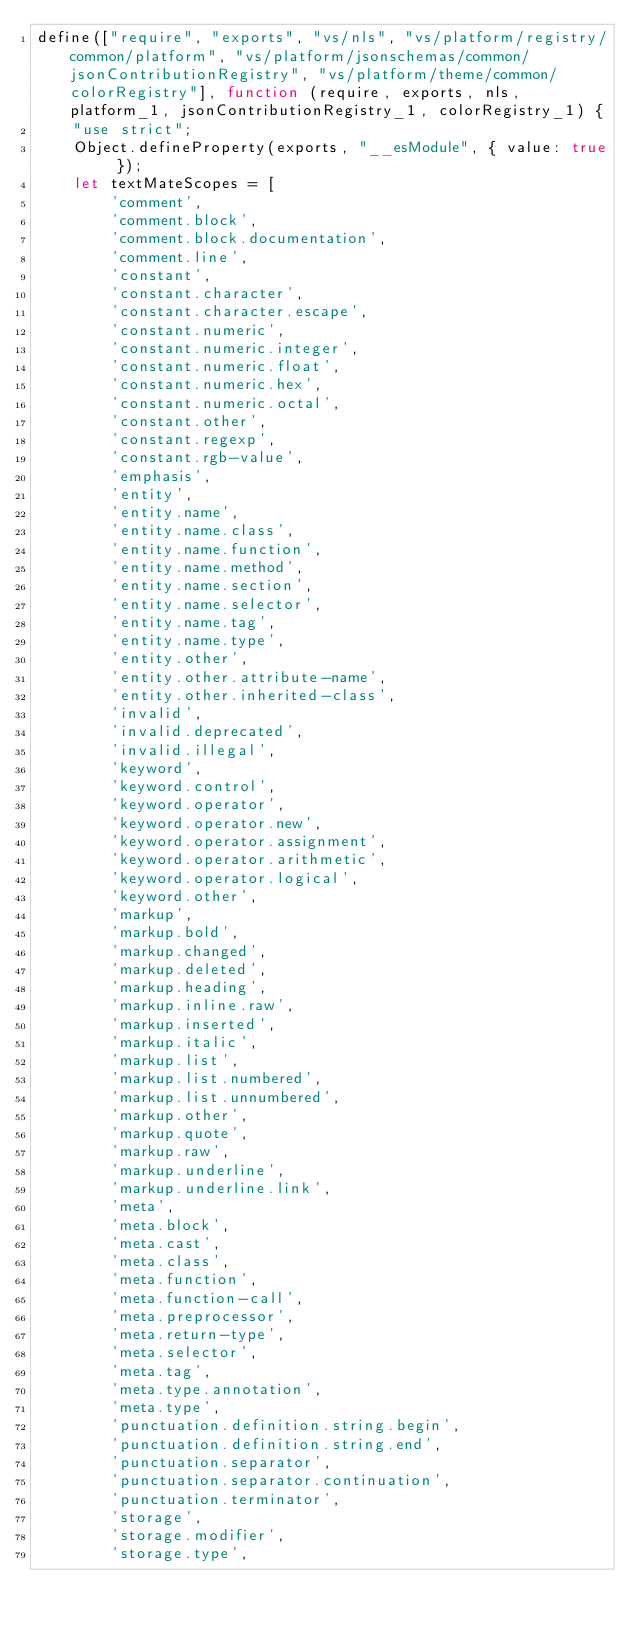Convert code to text. <code><loc_0><loc_0><loc_500><loc_500><_JavaScript_>define(["require", "exports", "vs/nls", "vs/platform/registry/common/platform", "vs/platform/jsonschemas/common/jsonContributionRegistry", "vs/platform/theme/common/colorRegistry"], function (require, exports, nls, platform_1, jsonContributionRegistry_1, colorRegistry_1) {
    "use strict";
    Object.defineProperty(exports, "__esModule", { value: true });
    let textMateScopes = [
        'comment',
        'comment.block',
        'comment.block.documentation',
        'comment.line',
        'constant',
        'constant.character',
        'constant.character.escape',
        'constant.numeric',
        'constant.numeric.integer',
        'constant.numeric.float',
        'constant.numeric.hex',
        'constant.numeric.octal',
        'constant.other',
        'constant.regexp',
        'constant.rgb-value',
        'emphasis',
        'entity',
        'entity.name',
        'entity.name.class',
        'entity.name.function',
        'entity.name.method',
        'entity.name.section',
        'entity.name.selector',
        'entity.name.tag',
        'entity.name.type',
        'entity.other',
        'entity.other.attribute-name',
        'entity.other.inherited-class',
        'invalid',
        'invalid.deprecated',
        'invalid.illegal',
        'keyword',
        'keyword.control',
        'keyword.operator',
        'keyword.operator.new',
        'keyword.operator.assignment',
        'keyword.operator.arithmetic',
        'keyword.operator.logical',
        'keyword.other',
        'markup',
        'markup.bold',
        'markup.changed',
        'markup.deleted',
        'markup.heading',
        'markup.inline.raw',
        'markup.inserted',
        'markup.italic',
        'markup.list',
        'markup.list.numbered',
        'markup.list.unnumbered',
        'markup.other',
        'markup.quote',
        'markup.raw',
        'markup.underline',
        'markup.underline.link',
        'meta',
        'meta.block',
        'meta.cast',
        'meta.class',
        'meta.function',
        'meta.function-call',
        'meta.preprocessor',
        'meta.return-type',
        'meta.selector',
        'meta.tag',
        'meta.type.annotation',
        'meta.type',
        'punctuation.definition.string.begin',
        'punctuation.definition.string.end',
        'punctuation.separator',
        'punctuation.separator.continuation',
        'punctuation.terminator',
        'storage',
        'storage.modifier',
        'storage.type',</code> 